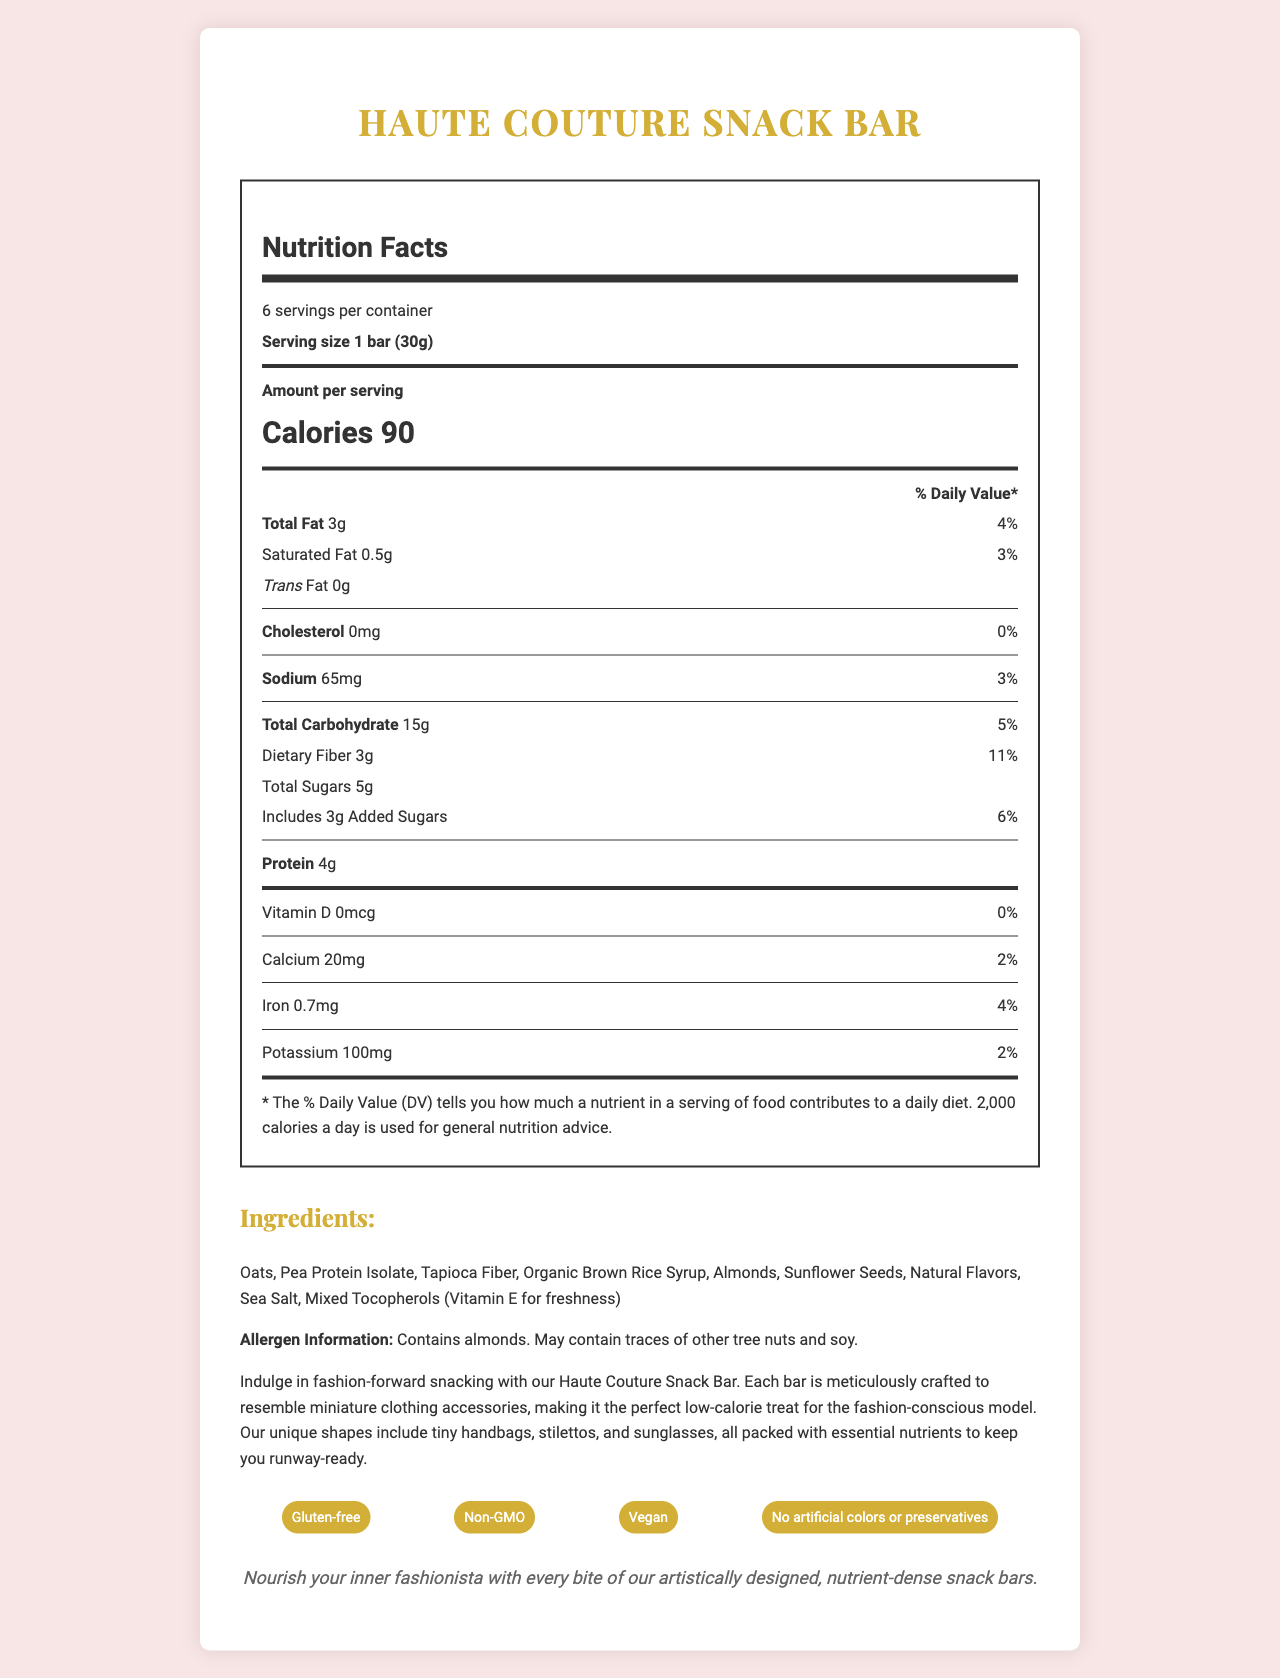what is the product name? The product name "Haute Couture Snack Bar" is mentioned at the top of the document title and in the first heading.
Answer: Haute Couture Snack Bar how many servings are there per container? The document states that there are 6 servings per container.
Answer: 6 servings what is the serving size? The serving size is mentioned as "1 bar (30g)" in the document.
Answer: 1 bar (30g) how many calories are in one serving? The document specifies that there are 90 calories per serving.
Answer: 90 calories what allergens does the product contain? The allergen information provided in the document states that the product contains almonds and may contain traces of other tree nuts and soy.
Answer: almonds and possibly traces of other tree nuts and soy what is the percentage of daily value for dietary fiber per serving? The daily value for dietary fiber per serving is indicated as 11% in the document.
Answer: 11% how much protein does each serving of the snack bar have? Each serving contains 4g of protein as stated in the document.
Answer: 4g what are the ingredients in the snack bar? The ingredients list is provided in the document.
Answer: Oats, Pea Protein Isolate, Tapioca Fiber, Organic Brown Rice Syrup, Almonds, Sunflower Seeds, Natural Flavors, Sea Salt, Mixed Tocopherols (Vitamin E for freshness) what are the special features of the Haute Couture Snack Bar? The special features include being gluten-free, non-GMO, vegan, and having no artificial colors or preservatives.
Answer: Gluten-free, Non-GMO, Vegan, No artificial colors or preservatives which vitamin is present at 0% daily value? The document indicates that Vitamin D is present at 0% daily value.
Answer: Vitamin D how much sodium is in one serving? The document specifies that there are 65mg of sodium per serving.
Answer: 65mg how many grams of total carbohydrates are in one serving? The document specifies that there are 15g of total carbohydrates per serving.
Answer: 15g what is the brand statement of the product? The brand statement is provided at the end of the document.
Answer: Nourish your inner fashionista with every bite of our artistically designed, nutrient-dense snack bars. what is the amount of total sugars per serving? The document states that there are 5g of total sugars per serving.
Answer: 5g what is the product description? The product description is provided in the document.
Answer: Indulge in fashion-forward snacking with our Haute Couture Snack Bar. Each bar is meticulously crafted to resemble miniature clothing accessories, making it the perfect low-calorie treat for the fashion-conscious model. Our unique shapes include tiny handbags, stilettos, and sunglasses, all packed with essential nutrients to keep you runway-ready. what essential nutrients are contained in the snack bar? A. Protein B. Dietary Fiber C. Total Sugars D. All of the above The document lists protein, dietary fiber, and total sugars as components, so the answer is all of the above.
Answer: D. All of the above which special feature is NOT true about the Haute Couture Snack Bar? A. Contains artificial colors B. Gluten-free C. Non-GMO D. Vegan The document lists that the Haute Couture Snack Bar is gluten-free, non-GMO, and vegan, but does not contain artificial colors, so the correct answer is "Contains artificial colors."
Answer: A. Contains artificial colors is the snack bar high in cholesterol? The document states that the snack bar contains 0mg of cholesterol, meaning it is not high in cholesterol.
Answer: No summarize the main idea of the document. The document serves to inform about the Haute Couture Snack Bar's nutritional facts, ingredients, special features, allergen information, and its fashion-forward product description.
Answer: The document provides detailed nutritional information and unique selling points for the Haute Couture Snack Bar, a low-calorie snack designed to resemble miniature clothing accessories. It highlights the bar's nutritional content, special features, and brand statement, targeting fashion-conscious individuals. how much iron does the snack bar provide per serving? The document states that each serving provides 0.7mg of iron.
Answer: 0.7mg what is the main dietary restriction accommodated by the Haute Couture Snack Bar? The document specifies that one of the special features of the snack bar is being gluten-free.
Answer: Gluten-free who would be the ideal consumer for the Haute Couture Snack Bar? The document describes the product as being suitable for fashion-conscious models.
Answer: Fashion-conscious models how many calories are there from fat in one serving? The document does not provide specific information on calories from fat, so this cannot be determined.
Answer: Not enough information 